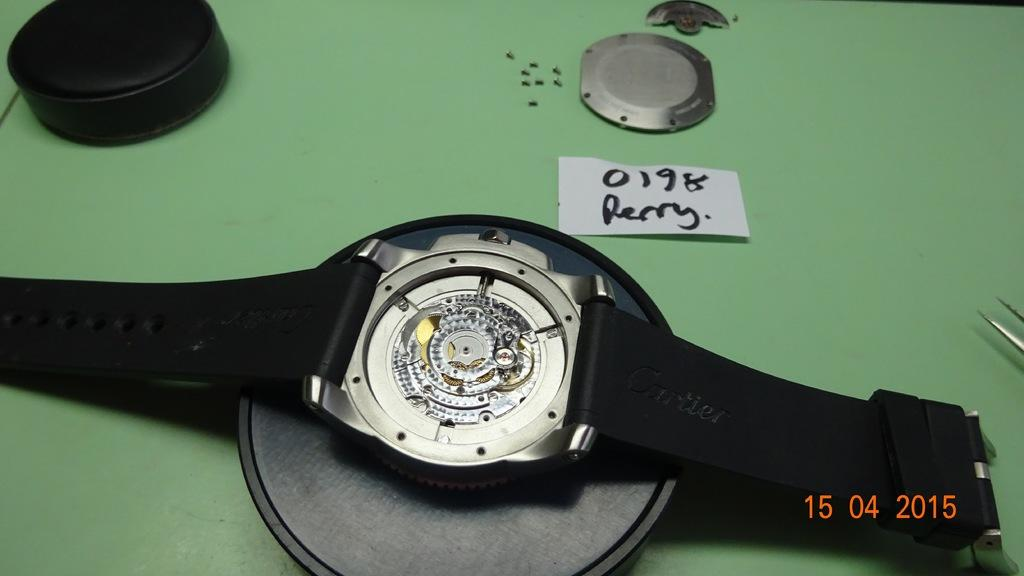<image>
Summarize the visual content of the image. back of a watch that says 0198 Perry, and has the date 15 04 2015. 